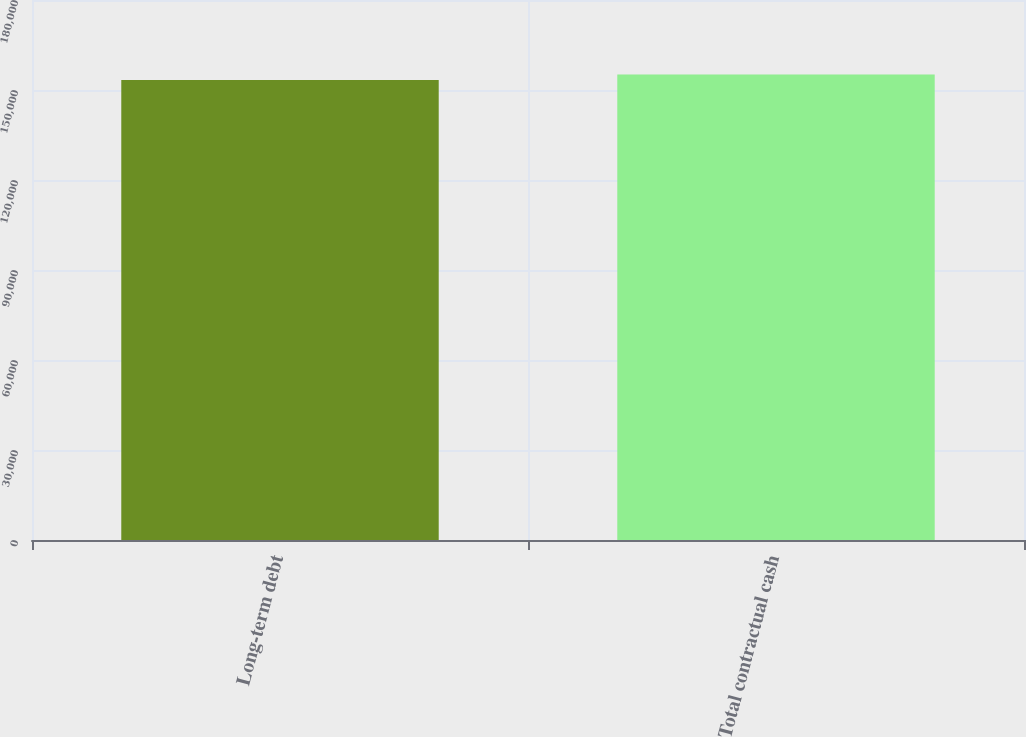Convert chart. <chart><loc_0><loc_0><loc_500><loc_500><bar_chart><fcel>Long-term debt<fcel>Total contractual cash<nl><fcel>153327<fcel>155127<nl></chart> 